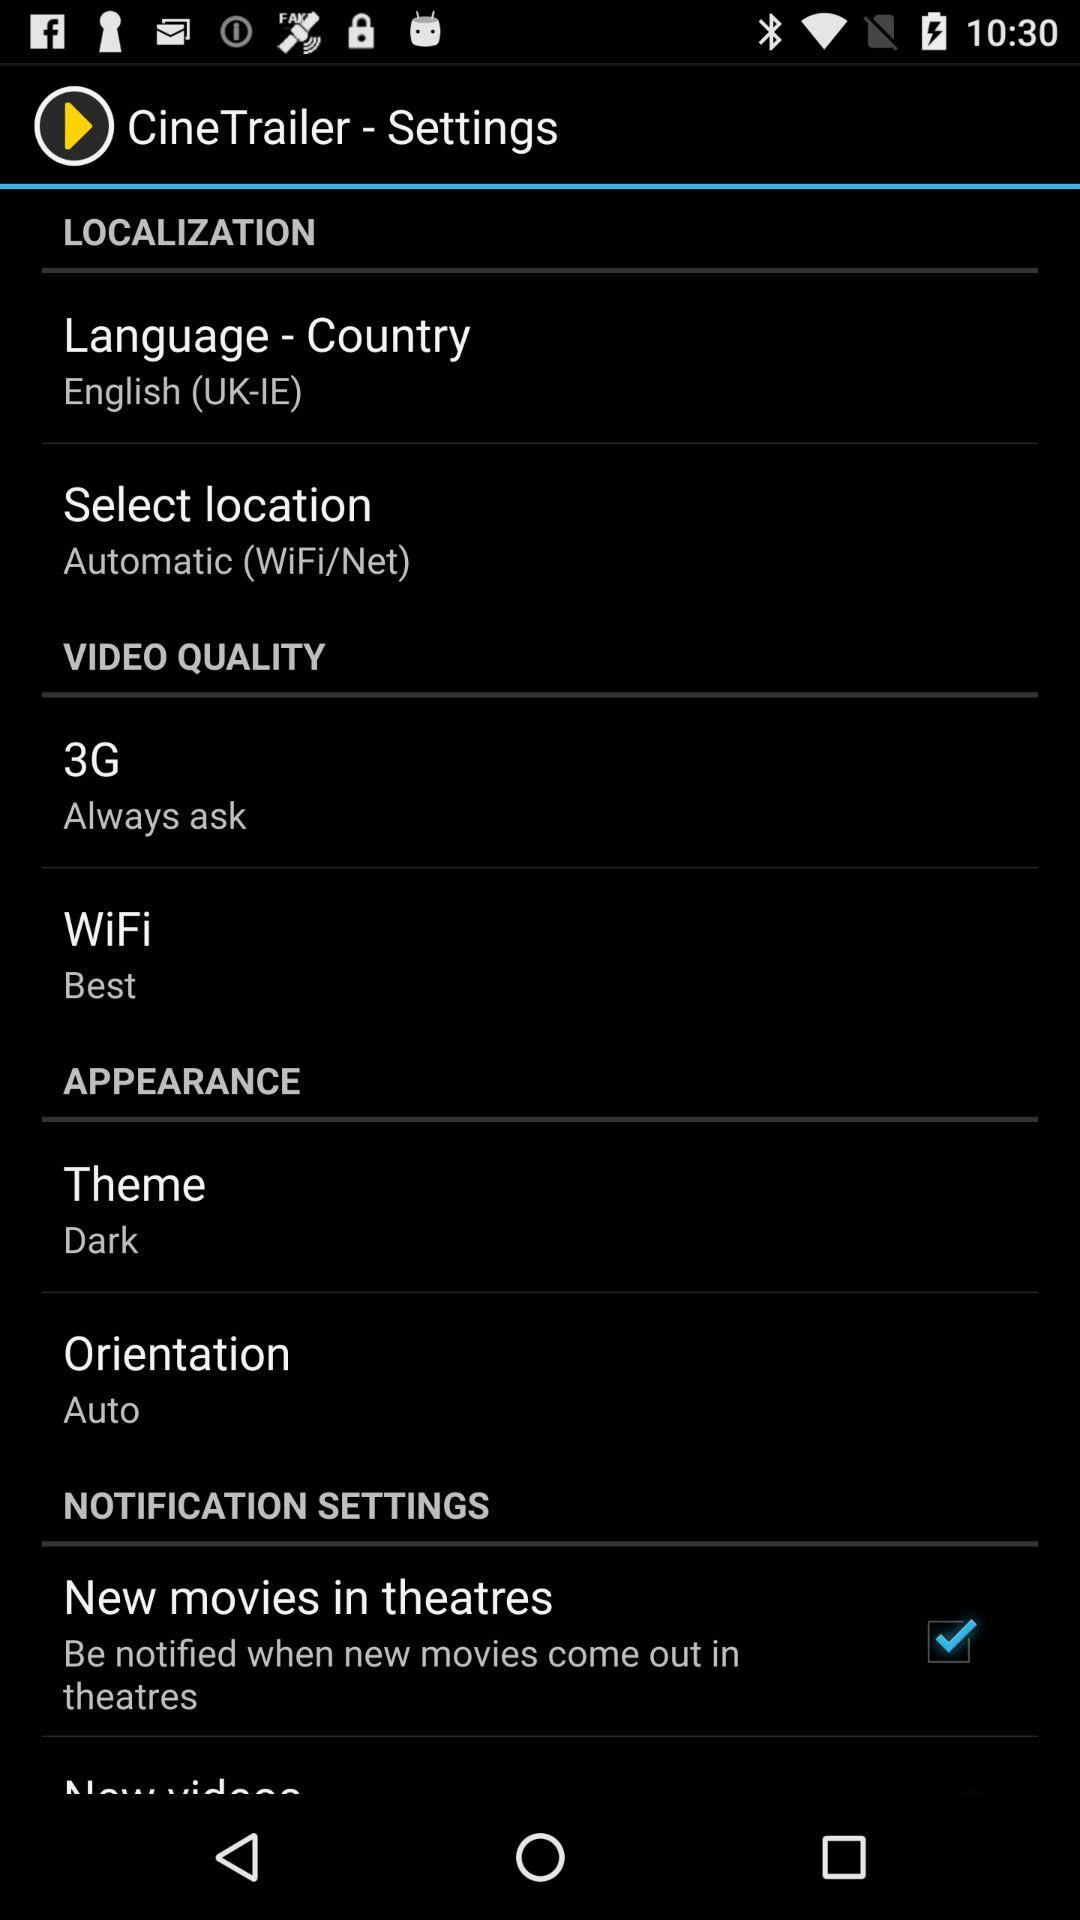What is the selected "WiFi"? The selected "WiFi" is "Best". 